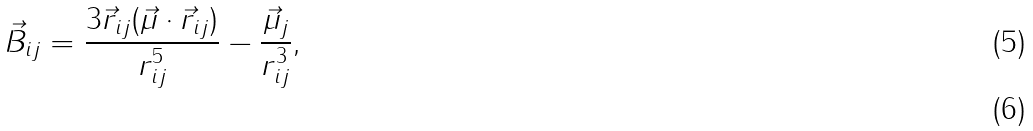Convert formula to latex. <formula><loc_0><loc_0><loc_500><loc_500>\vec { B } _ { i j } = \frac { 3 \vec { r } _ { i j } ( \vec { \mu } \cdot \vec { r } _ { i j } ) } { r _ { i j } ^ { 5 } } - \frac { \vec { \mu } _ { j } } { r _ { i j } ^ { 3 } } , \\</formula> 